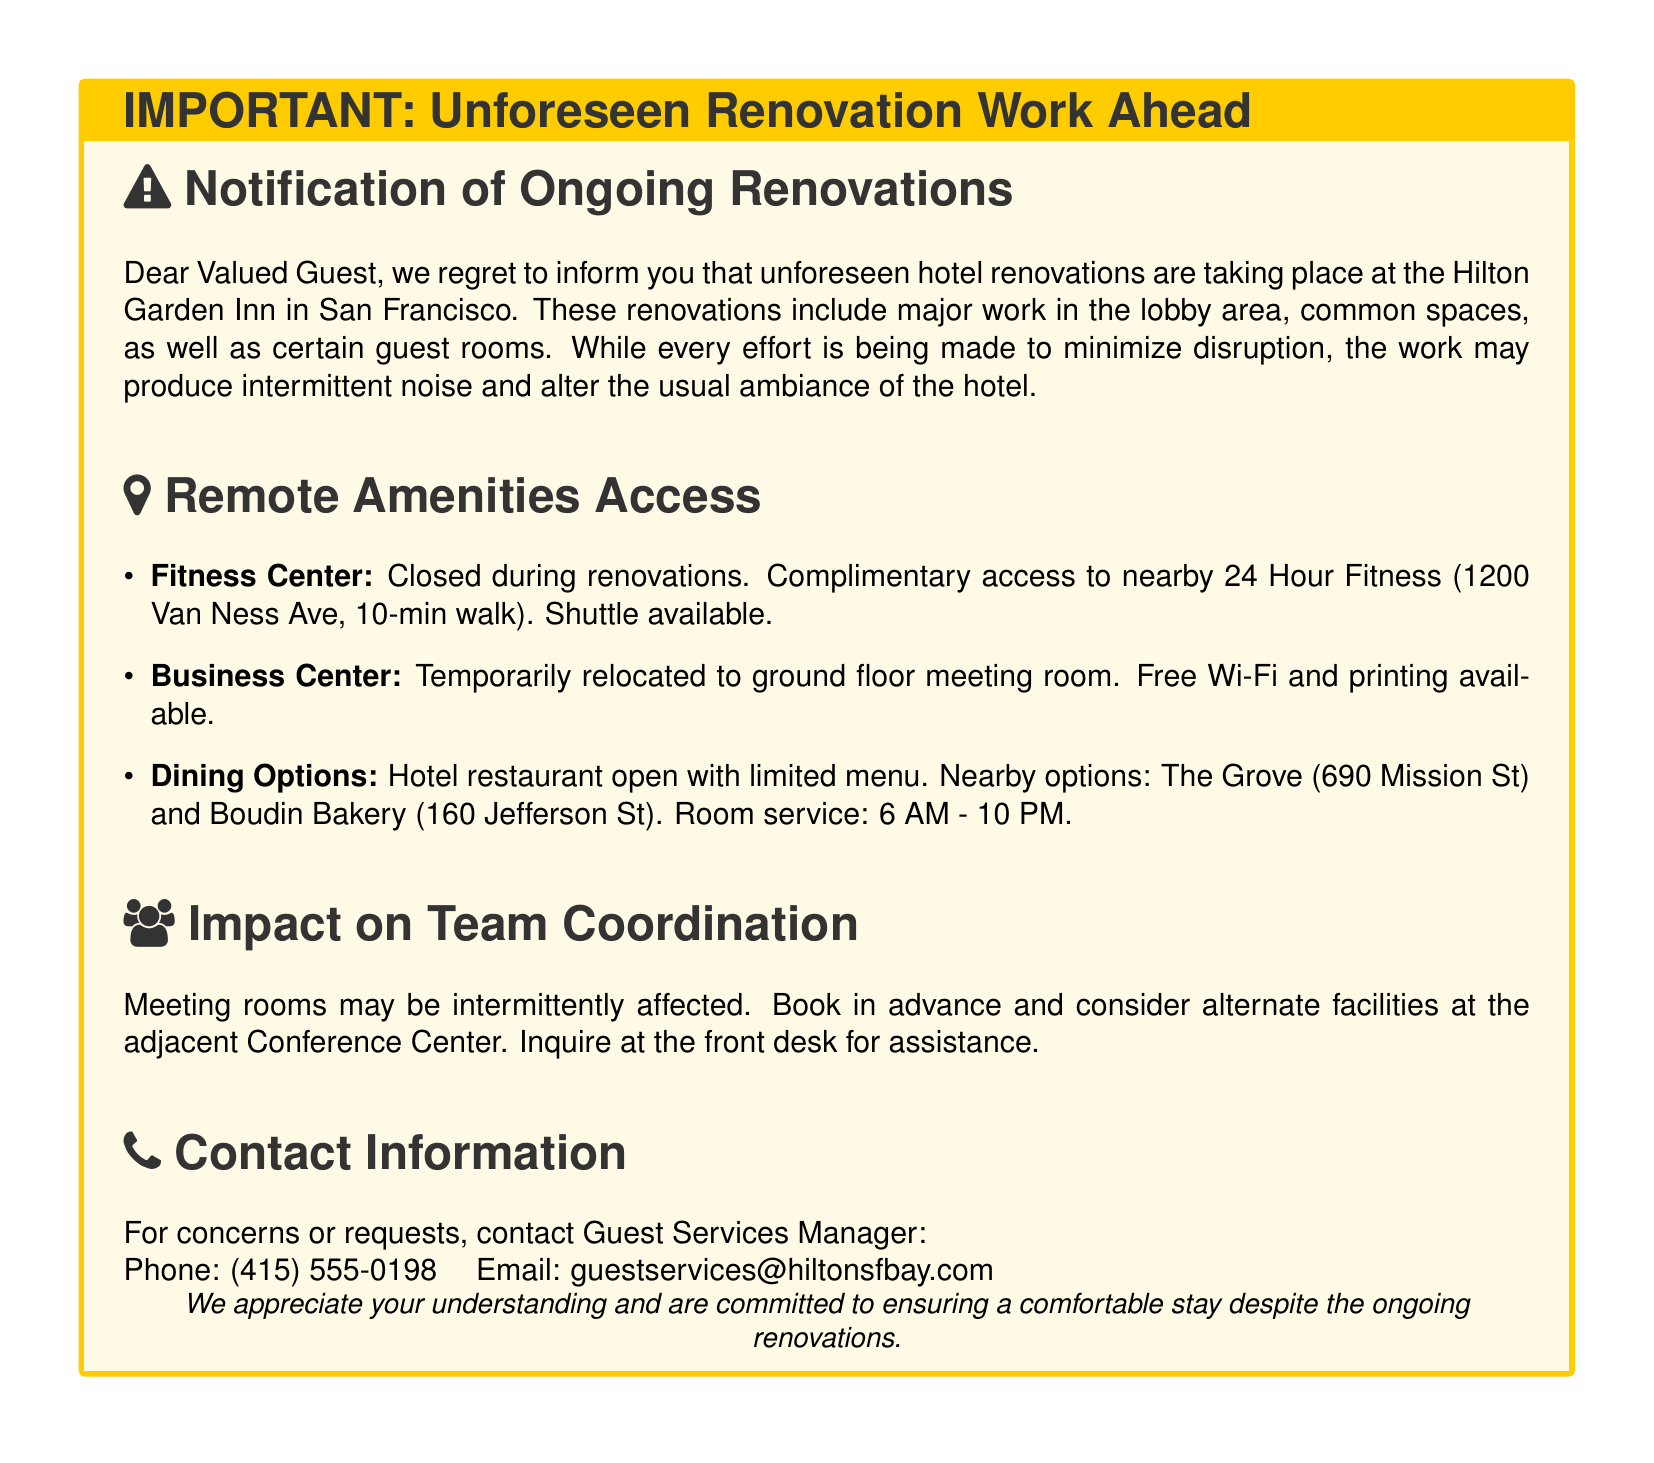What renovations are taking place? The document states that minor and major work is being done in the lobby area, common spaces, and certain guest rooms.
Answer: Lobby area, common spaces, guest rooms When is room service available? The document notes the operating hours for room service as mentioned under Dining Options.
Answer: 6 AM - 10 PM Where can guests access a fitness center? The document specifies that guests can access a nearby 24 Hour Fitness, including the address.
Answer: 1200 Van Ness Ave What is the contact number for Guest Services? The contact information section provides a phone number for concerns or requests.
Answer: (415) 555-0198 What should teams consider about meeting rooms? The document advises that meeting rooms may be intermittently affected and suggests booking in advance.
Answer: Book in advance What is being done to minimize disruption from renovations? The document mentions that every effort is being made to minimize disruption during renovations.
Answer: Every effort is made What dining option is offered with a limited menu? The document mentions the name of the hotel restaurant that remains open with a limited menu.
Answer: Hotel restaurant 